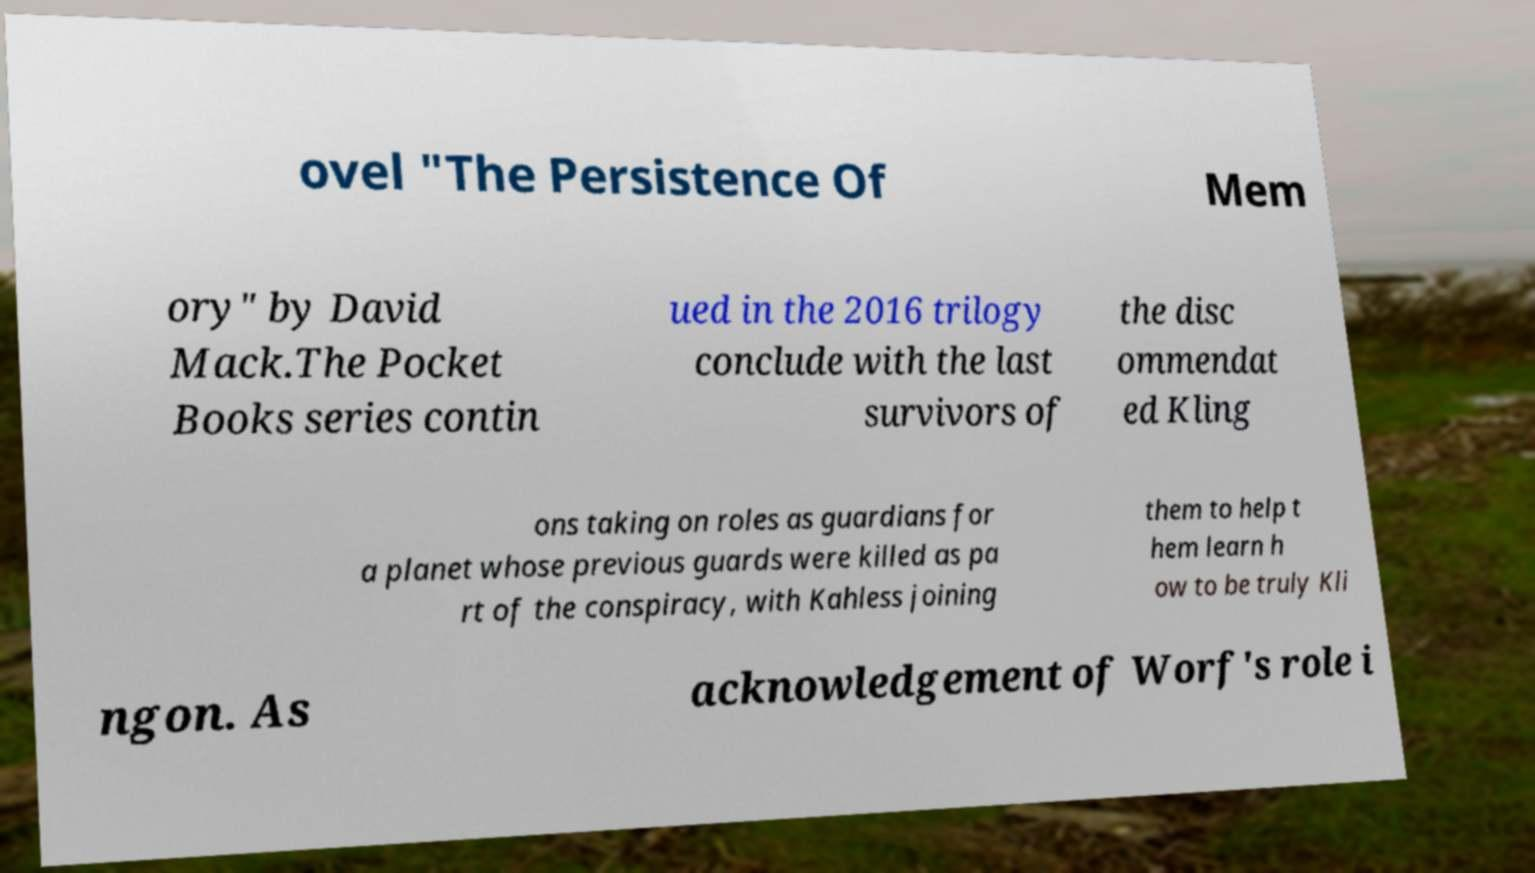I need the written content from this picture converted into text. Can you do that? ovel "The Persistence Of Mem ory" by David Mack.The Pocket Books series contin ued in the 2016 trilogy conclude with the last survivors of the disc ommendat ed Kling ons taking on roles as guardians for a planet whose previous guards were killed as pa rt of the conspiracy, with Kahless joining them to help t hem learn h ow to be truly Kli ngon. As acknowledgement of Worf's role i 